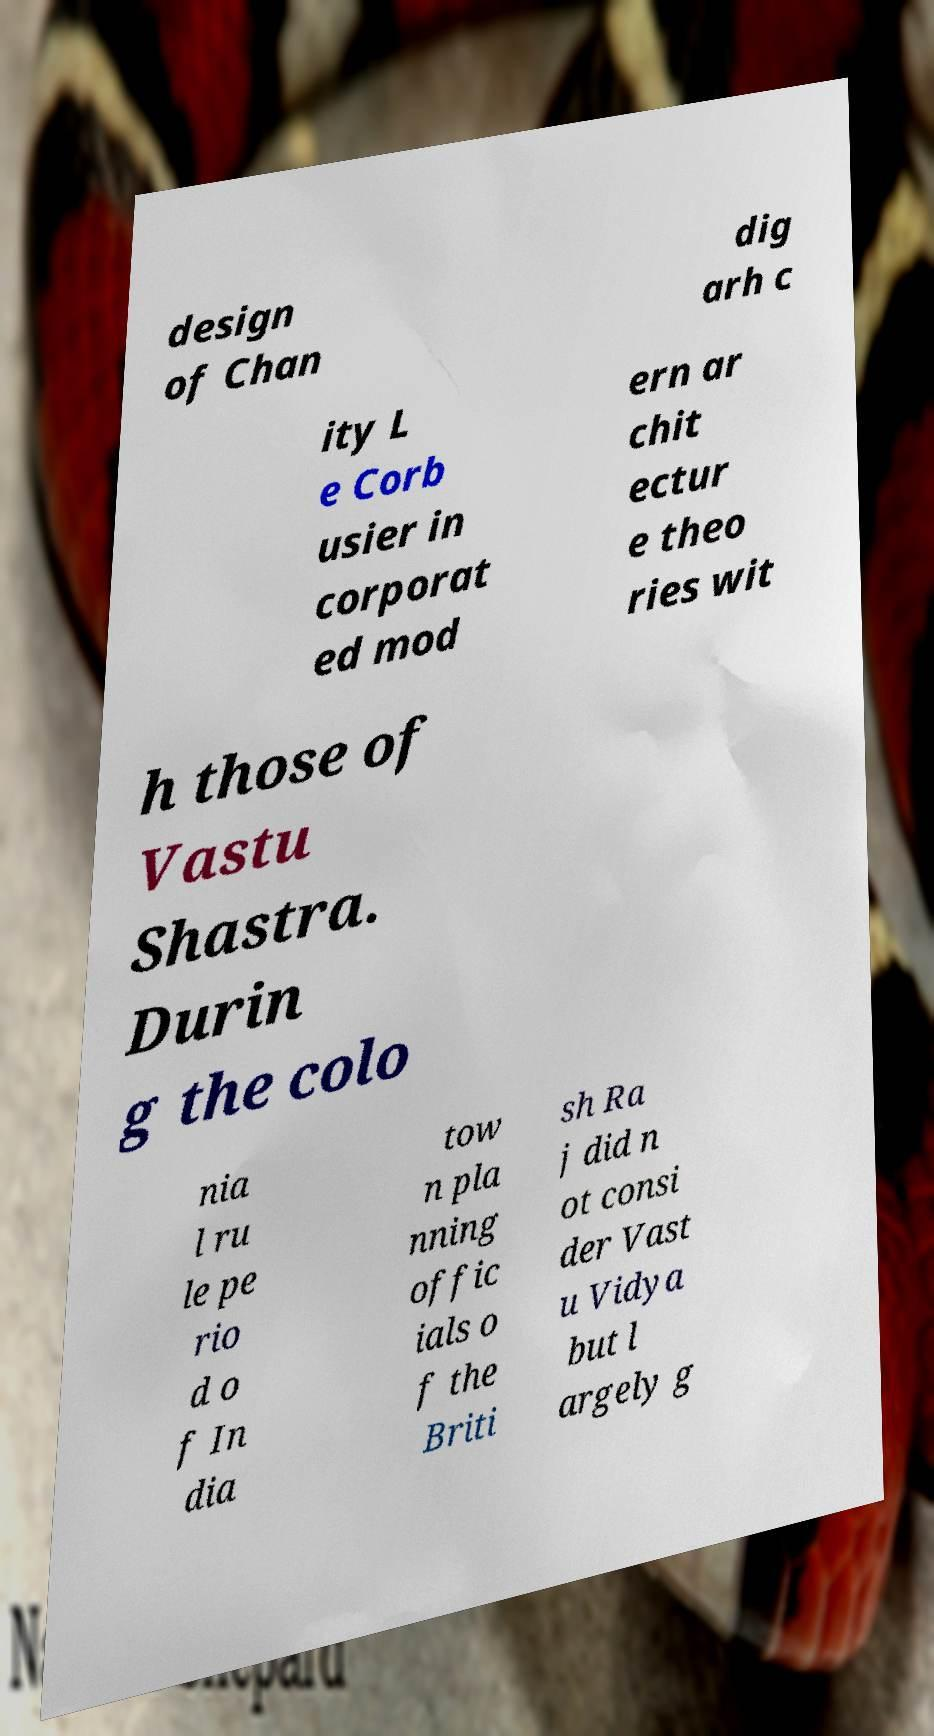Could you extract and type out the text from this image? design of Chan dig arh c ity L e Corb usier in corporat ed mod ern ar chit ectur e theo ries wit h those of Vastu Shastra. Durin g the colo nia l ru le pe rio d o f In dia tow n pla nning offic ials o f the Briti sh Ra j did n ot consi der Vast u Vidya but l argely g 